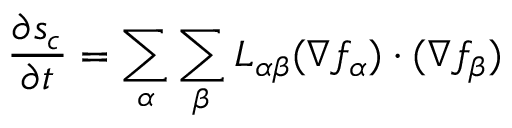<formula> <loc_0><loc_0><loc_500><loc_500>{ \frac { \partial s _ { c } } { \partial t } } = \sum _ { \alpha } \sum _ { \beta } L _ { \alpha \beta } ( \nabla f _ { \alpha } ) \cdot ( \nabla f _ { \beta } )</formula> 